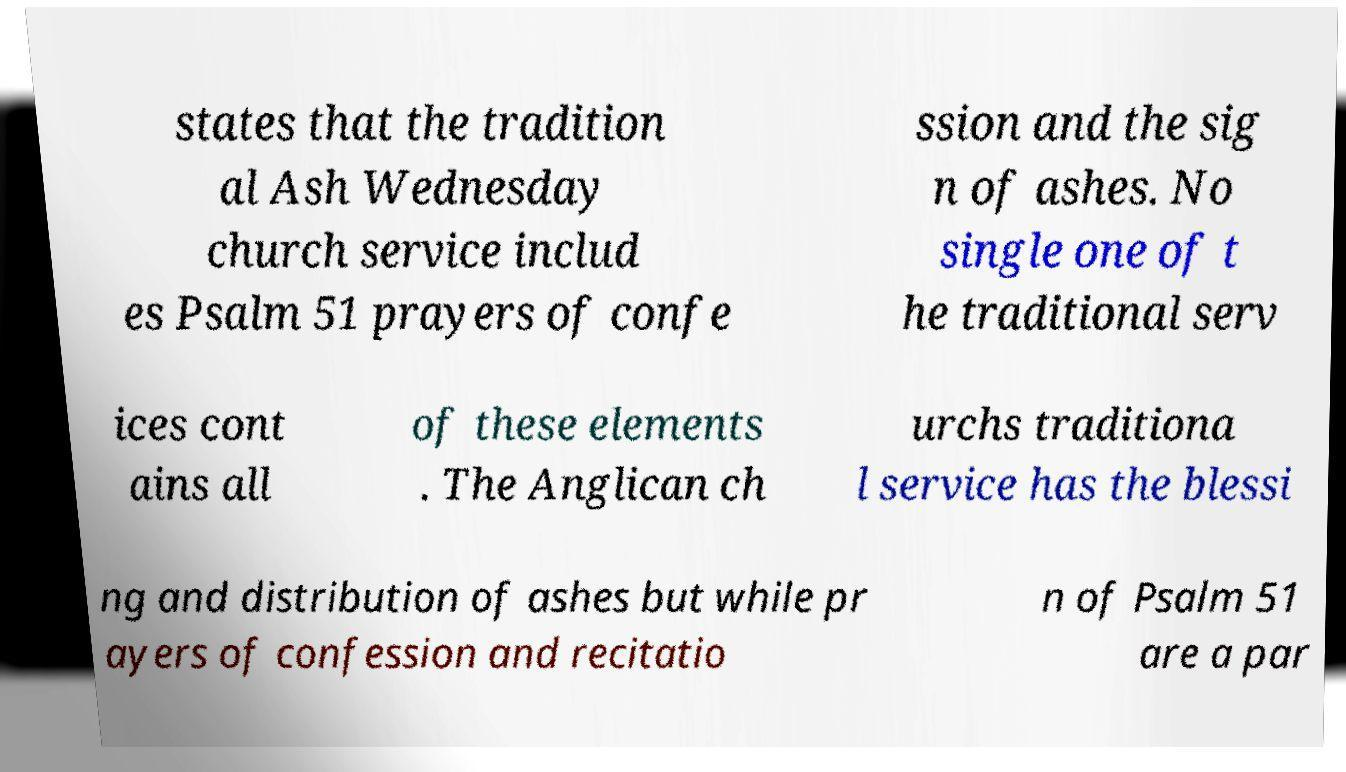Can you accurately transcribe the text from the provided image for me? states that the tradition al Ash Wednesday church service includ es Psalm 51 prayers of confe ssion and the sig n of ashes. No single one of t he traditional serv ices cont ains all of these elements . The Anglican ch urchs traditiona l service has the blessi ng and distribution of ashes but while pr ayers of confession and recitatio n of Psalm 51 are a par 